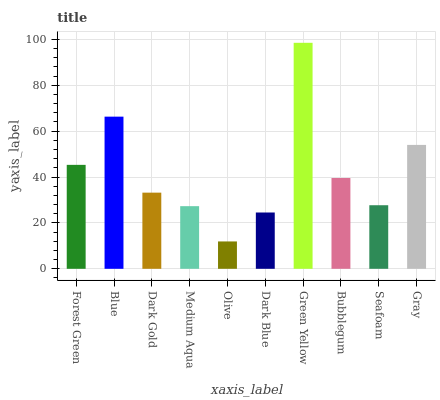Is Olive the minimum?
Answer yes or no. Yes. Is Green Yellow the maximum?
Answer yes or no. Yes. Is Blue the minimum?
Answer yes or no. No. Is Blue the maximum?
Answer yes or no. No. Is Blue greater than Forest Green?
Answer yes or no. Yes. Is Forest Green less than Blue?
Answer yes or no. Yes. Is Forest Green greater than Blue?
Answer yes or no. No. Is Blue less than Forest Green?
Answer yes or no. No. Is Bubblegum the high median?
Answer yes or no. Yes. Is Dark Gold the low median?
Answer yes or no. Yes. Is Dark Blue the high median?
Answer yes or no. No. Is Seafoam the low median?
Answer yes or no. No. 